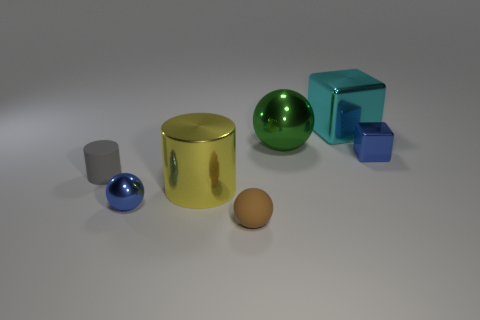Add 3 large green balls. How many objects exist? 10 Subtract all cylinders. How many objects are left? 5 Add 4 cyan rubber objects. How many cyan rubber objects exist? 4 Subtract 1 yellow cylinders. How many objects are left? 6 Subtract all large gray metal cylinders. Subtract all small blue metal cubes. How many objects are left? 6 Add 3 tiny brown rubber balls. How many tiny brown rubber balls are left? 4 